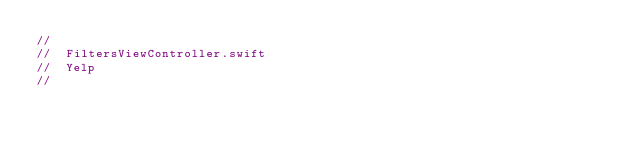Convert code to text. <code><loc_0><loc_0><loc_500><loc_500><_Swift_>//
//  FiltersViewController.swift
//  Yelp
//</code> 